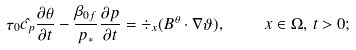Convert formula to latex. <formula><loc_0><loc_0><loc_500><loc_500>\tau _ { 0 } \hat { c _ { p } } \frac { \partial \theta } { \partial t } - \frac { \beta _ { 0 f } } { p _ { * } } \frac { \partial p } { \partial t } = \div _ { x } ( B ^ { \theta } \cdot \nabla \vartheta ) , \quad \ x \in \Omega , \, t > 0 ;</formula> 